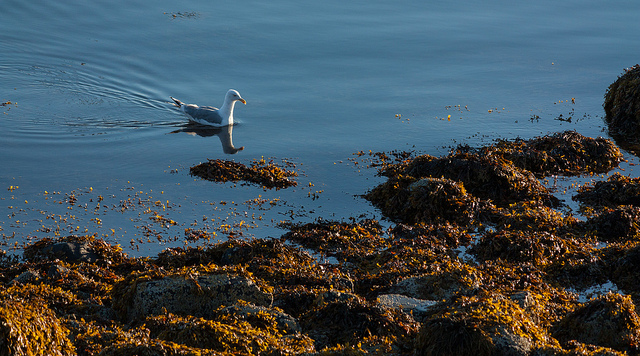What can you infer about the health of the ecosystem based on this image? While a comprehensive assessment would require more information, based on the image alone, the presence of seaweed and the clarity of water suggest a potentially healthy marine ecosystem. The bird, which appears in good health, is an indicator of adequate food resources and environmental quality. However, further investigation into local biodiversity, water quality, and other environmental factors would be necessary to draw more precise conclusions. 